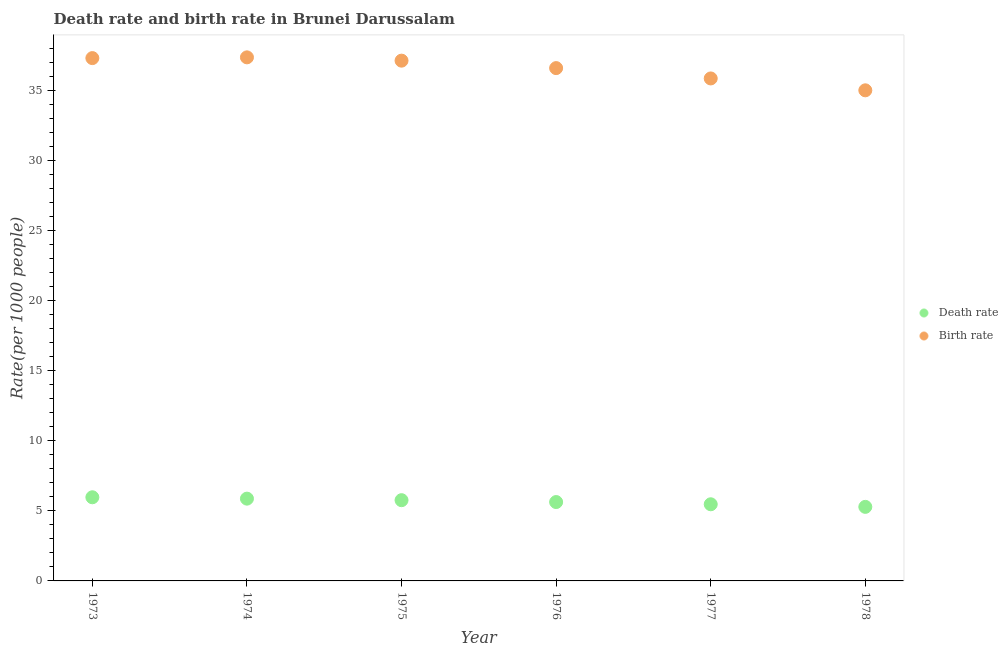What is the birth rate in 1974?
Ensure brevity in your answer.  37.39. Across all years, what is the maximum death rate?
Make the answer very short. 5.97. Across all years, what is the minimum birth rate?
Make the answer very short. 35.03. In which year was the birth rate maximum?
Provide a succinct answer. 1974. In which year was the death rate minimum?
Your response must be concise. 1978. What is the total birth rate in the graph?
Provide a succinct answer. 219.4. What is the difference between the death rate in 1976 and that in 1977?
Provide a succinct answer. 0.16. What is the difference between the birth rate in 1974 and the death rate in 1977?
Offer a terse response. 31.91. What is the average birth rate per year?
Offer a very short reply. 36.57. In the year 1975, what is the difference between the birth rate and death rate?
Provide a succinct answer. 31.38. What is the ratio of the death rate in 1974 to that in 1977?
Your answer should be compact. 1.07. Is the birth rate in 1975 less than that in 1978?
Your answer should be compact. No. What is the difference between the highest and the second highest death rate?
Ensure brevity in your answer.  0.1. What is the difference between the highest and the lowest birth rate?
Your answer should be very brief. 2.35. In how many years, is the death rate greater than the average death rate taken over all years?
Offer a terse response. 3. Does the birth rate monotonically increase over the years?
Your response must be concise. No. Is the death rate strictly greater than the birth rate over the years?
Your response must be concise. No. Are the values on the major ticks of Y-axis written in scientific E-notation?
Ensure brevity in your answer.  No. How are the legend labels stacked?
Offer a very short reply. Vertical. What is the title of the graph?
Offer a terse response. Death rate and birth rate in Brunei Darussalam. Does "Subsidies" appear as one of the legend labels in the graph?
Provide a short and direct response. No. What is the label or title of the X-axis?
Your answer should be very brief. Year. What is the label or title of the Y-axis?
Provide a succinct answer. Rate(per 1000 people). What is the Rate(per 1000 people) in Death rate in 1973?
Make the answer very short. 5.97. What is the Rate(per 1000 people) in Birth rate in 1973?
Offer a terse response. 37.33. What is the Rate(per 1000 people) in Death rate in 1974?
Provide a succinct answer. 5.88. What is the Rate(per 1000 people) of Birth rate in 1974?
Your response must be concise. 37.39. What is the Rate(per 1000 people) in Death rate in 1975?
Your answer should be very brief. 5.76. What is the Rate(per 1000 people) in Birth rate in 1975?
Offer a terse response. 37.15. What is the Rate(per 1000 people) of Death rate in 1976?
Offer a very short reply. 5.63. What is the Rate(per 1000 people) of Birth rate in 1976?
Keep it short and to the point. 36.62. What is the Rate(per 1000 people) in Death rate in 1977?
Ensure brevity in your answer.  5.47. What is the Rate(per 1000 people) in Birth rate in 1977?
Keep it short and to the point. 35.88. What is the Rate(per 1000 people) of Death rate in 1978?
Provide a short and direct response. 5.29. What is the Rate(per 1000 people) of Birth rate in 1978?
Keep it short and to the point. 35.03. Across all years, what is the maximum Rate(per 1000 people) in Death rate?
Give a very brief answer. 5.97. Across all years, what is the maximum Rate(per 1000 people) of Birth rate?
Your answer should be very brief. 37.39. Across all years, what is the minimum Rate(per 1000 people) in Death rate?
Ensure brevity in your answer.  5.29. Across all years, what is the minimum Rate(per 1000 people) of Birth rate?
Offer a very short reply. 35.03. What is the total Rate(per 1000 people) in Death rate in the graph?
Provide a succinct answer. 34.01. What is the total Rate(per 1000 people) of Birth rate in the graph?
Your answer should be compact. 219.4. What is the difference between the Rate(per 1000 people) in Death rate in 1973 and that in 1974?
Offer a terse response. 0.1. What is the difference between the Rate(per 1000 people) of Birth rate in 1973 and that in 1974?
Your response must be concise. -0.05. What is the difference between the Rate(per 1000 people) in Death rate in 1973 and that in 1975?
Keep it short and to the point. 0.21. What is the difference between the Rate(per 1000 people) in Birth rate in 1973 and that in 1975?
Provide a short and direct response. 0.18. What is the difference between the Rate(per 1000 people) in Death rate in 1973 and that in 1976?
Your answer should be very brief. 0.34. What is the difference between the Rate(per 1000 people) of Birth rate in 1973 and that in 1976?
Ensure brevity in your answer.  0.71. What is the difference between the Rate(per 1000 people) of Death rate in 1973 and that in 1977?
Offer a terse response. 0.5. What is the difference between the Rate(per 1000 people) of Birth rate in 1973 and that in 1977?
Offer a terse response. 1.45. What is the difference between the Rate(per 1000 people) of Death rate in 1973 and that in 1978?
Your response must be concise. 0.69. What is the difference between the Rate(per 1000 people) of Birth rate in 1973 and that in 1978?
Ensure brevity in your answer.  2.3. What is the difference between the Rate(per 1000 people) of Death rate in 1974 and that in 1975?
Provide a succinct answer. 0.11. What is the difference between the Rate(per 1000 people) of Birth rate in 1974 and that in 1975?
Give a very brief answer. 0.24. What is the difference between the Rate(per 1000 people) in Death rate in 1974 and that in 1976?
Give a very brief answer. 0.24. What is the difference between the Rate(per 1000 people) of Birth rate in 1974 and that in 1976?
Ensure brevity in your answer.  0.77. What is the difference between the Rate(per 1000 people) in Death rate in 1974 and that in 1977?
Provide a short and direct response. 0.4. What is the difference between the Rate(per 1000 people) in Birth rate in 1974 and that in 1977?
Give a very brief answer. 1.51. What is the difference between the Rate(per 1000 people) in Death rate in 1974 and that in 1978?
Offer a terse response. 0.59. What is the difference between the Rate(per 1000 people) of Birth rate in 1974 and that in 1978?
Offer a very short reply. 2.35. What is the difference between the Rate(per 1000 people) of Death rate in 1975 and that in 1976?
Give a very brief answer. 0.13. What is the difference between the Rate(per 1000 people) of Birth rate in 1975 and that in 1976?
Your response must be concise. 0.53. What is the difference between the Rate(per 1000 people) in Death rate in 1975 and that in 1977?
Provide a short and direct response. 0.29. What is the difference between the Rate(per 1000 people) in Birth rate in 1975 and that in 1977?
Your answer should be compact. 1.27. What is the difference between the Rate(per 1000 people) of Death rate in 1975 and that in 1978?
Offer a very short reply. 0.48. What is the difference between the Rate(per 1000 people) of Birth rate in 1975 and that in 1978?
Provide a short and direct response. 2.12. What is the difference between the Rate(per 1000 people) in Death rate in 1976 and that in 1977?
Your answer should be compact. 0.16. What is the difference between the Rate(per 1000 people) of Birth rate in 1976 and that in 1977?
Your answer should be very brief. 0.74. What is the difference between the Rate(per 1000 people) of Death rate in 1976 and that in 1978?
Your response must be concise. 0.34. What is the difference between the Rate(per 1000 people) of Birth rate in 1976 and that in 1978?
Offer a terse response. 1.59. What is the difference between the Rate(per 1000 people) in Death rate in 1977 and that in 1978?
Offer a terse response. 0.18. What is the difference between the Rate(per 1000 people) of Birth rate in 1977 and that in 1978?
Provide a succinct answer. 0.85. What is the difference between the Rate(per 1000 people) in Death rate in 1973 and the Rate(per 1000 people) in Birth rate in 1974?
Make the answer very short. -31.41. What is the difference between the Rate(per 1000 people) of Death rate in 1973 and the Rate(per 1000 people) of Birth rate in 1975?
Your response must be concise. -31.18. What is the difference between the Rate(per 1000 people) of Death rate in 1973 and the Rate(per 1000 people) of Birth rate in 1976?
Provide a short and direct response. -30.64. What is the difference between the Rate(per 1000 people) of Death rate in 1973 and the Rate(per 1000 people) of Birth rate in 1977?
Your response must be concise. -29.91. What is the difference between the Rate(per 1000 people) in Death rate in 1973 and the Rate(per 1000 people) in Birth rate in 1978?
Keep it short and to the point. -29.06. What is the difference between the Rate(per 1000 people) in Death rate in 1974 and the Rate(per 1000 people) in Birth rate in 1975?
Offer a very short reply. -31.27. What is the difference between the Rate(per 1000 people) of Death rate in 1974 and the Rate(per 1000 people) of Birth rate in 1976?
Provide a short and direct response. -30.74. What is the difference between the Rate(per 1000 people) in Death rate in 1974 and the Rate(per 1000 people) in Birth rate in 1977?
Offer a very short reply. -30. What is the difference between the Rate(per 1000 people) of Death rate in 1974 and the Rate(per 1000 people) of Birth rate in 1978?
Your answer should be compact. -29.16. What is the difference between the Rate(per 1000 people) of Death rate in 1975 and the Rate(per 1000 people) of Birth rate in 1976?
Your response must be concise. -30.85. What is the difference between the Rate(per 1000 people) in Death rate in 1975 and the Rate(per 1000 people) in Birth rate in 1977?
Your response must be concise. -30.11. What is the difference between the Rate(per 1000 people) in Death rate in 1975 and the Rate(per 1000 people) in Birth rate in 1978?
Keep it short and to the point. -29.27. What is the difference between the Rate(per 1000 people) in Death rate in 1976 and the Rate(per 1000 people) in Birth rate in 1977?
Keep it short and to the point. -30.25. What is the difference between the Rate(per 1000 people) in Death rate in 1976 and the Rate(per 1000 people) in Birth rate in 1978?
Ensure brevity in your answer.  -29.4. What is the difference between the Rate(per 1000 people) of Death rate in 1977 and the Rate(per 1000 people) of Birth rate in 1978?
Provide a short and direct response. -29.56. What is the average Rate(per 1000 people) of Death rate per year?
Keep it short and to the point. 5.67. What is the average Rate(per 1000 people) in Birth rate per year?
Provide a short and direct response. 36.57. In the year 1973, what is the difference between the Rate(per 1000 people) in Death rate and Rate(per 1000 people) in Birth rate?
Offer a very short reply. -31.36. In the year 1974, what is the difference between the Rate(per 1000 people) in Death rate and Rate(per 1000 people) in Birth rate?
Keep it short and to the point. -31.51. In the year 1975, what is the difference between the Rate(per 1000 people) in Death rate and Rate(per 1000 people) in Birth rate?
Offer a very short reply. -31.39. In the year 1976, what is the difference between the Rate(per 1000 people) in Death rate and Rate(per 1000 people) in Birth rate?
Offer a terse response. -30.99. In the year 1977, what is the difference between the Rate(per 1000 people) in Death rate and Rate(per 1000 people) in Birth rate?
Your answer should be very brief. -30.41. In the year 1978, what is the difference between the Rate(per 1000 people) in Death rate and Rate(per 1000 people) in Birth rate?
Your response must be concise. -29.74. What is the ratio of the Rate(per 1000 people) of Death rate in 1973 to that in 1974?
Ensure brevity in your answer.  1.02. What is the ratio of the Rate(per 1000 people) of Death rate in 1973 to that in 1975?
Make the answer very short. 1.04. What is the ratio of the Rate(per 1000 people) of Birth rate in 1973 to that in 1975?
Ensure brevity in your answer.  1. What is the ratio of the Rate(per 1000 people) of Death rate in 1973 to that in 1976?
Provide a succinct answer. 1.06. What is the ratio of the Rate(per 1000 people) in Birth rate in 1973 to that in 1976?
Offer a very short reply. 1.02. What is the ratio of the Rate(per 1000 people) of Death rate in 1973 to that in 1977?
Provide a succinct answer. 1.09. What is the ratio of the Rate(per 1000 people) in Birth rate in 1973 to that in 1977?
Provide a succinct answer. 1.04. What is the ratio of the Rate(per 1000 people) of Death rate in 1973 to that in 1978?
Provide a short and direct response. 1.13. What is the ratio of the Rate(per 1000 people) of Birth rate in 1973 to that in 1978?
Your answer should be compact. 1.07. What is the ratio of the Rate(per 1000 people) of Death rate in 1974 to that in 1975?
Keep it short and to the point. 1.02. What is the ratio of the Rate(per 1000 people) in Birth rate in 1974 to that in 1975?
Offer a terse response. 1.01. What is the ratio of the Rate(per 1000 people) in Death rate in 1974 to that in 1976?
Offer a terse response. 1.04. What is the ratio of the Rate(per 1000 people) in Birth rate in 1974 to that in 1976?
Provide a short and direct response. 1.02. What is the ratio of the Rate(per 1000 people) in Death rate in 1974 to that in 1977?
Provide a succinct answer. 1.07. What is the ratio of the Rate(per 1000 people) of Birth rate in 1974 to that in 1977?
Provide a short and direct response. 1.04. What is the ratio of the Rate(per 1000 people) of Death rate in 1974 to that in 1978?
Make the answer very short. 1.11. What is the ratio of the Rate(per 1000 people) of Birth rate in 1974 to that in 1978?
Your answer should be very brief. 1.07. What is the ratio of the Rate(per 1000 people) of Death rate in 1975 to that in 1976?
Provide a short and direct response. 1.02. What is the ratio of the Rate(per 1000 people) of Birth rate in 1975 to that in 1976?
Give a very brief answer. 1.01. What is the ratio of the Rate(per 1000 people) of Death rate in 1975 to that in 1977?
Offer a very short reply. 1.05. What is the ratio of the Rate(per 1000 people) in Birth rate in 1975 to that in 1977?
Make the answer very short. 1.04. What is the ratio of the Rate(per 1000 people) of Death rate in 1975 to that in 1978?
Offer a very short reply. 1.09. What is the ratio of the Rate(per 1000 people) of Birth rate in 1975 to that in 1978?
Provide a short and direct response. 1.06. What is the ratio of the Rate(per 1000 people) in Death rate in 1976 to that in 1977?
Your response must be concise. 1.03. What is the ratio of the Rate(per 1000 people) of Birth rate in 1976 to that in 1977?
Ensure brevity in your answer.  1.02. What is the ratio of the Rate(per 1000 people) of Death rate in 1976 to that in 1978?
Your answer should be very brief. 1.07. What is the ratio of the Rate(per 1000 people) of Birth rate in 1976 to that in 1978?
Provide a succinct answer. 1.05. What is the ratio of the Rate(per 1000 people) of Death rate in 1977 to that in 1978?
Keep it short and to the point. 1.03. What is the ratio of the Rate(per 1000 people) of Birth rate in 1977 to that in 1978?
Your answer should be compact. 1.02. What is the difference between the highest and the second highest Rate(per 1000 people) in Death rate?
Your response must be concise. 0.1. What is the difference between the highest and the second highest Rate(per 1000 people) in Birth rate?
Give a very brief answer. 0.05. What is the difference between the highest and the lowest Rate(per 1000 people) of Death rate?
Your answer should be very brief. 0.69. What is the difference between the highest and the lowest Rate(per 1000 people) of Birth rate?
Your response must be concise. 2.35. 